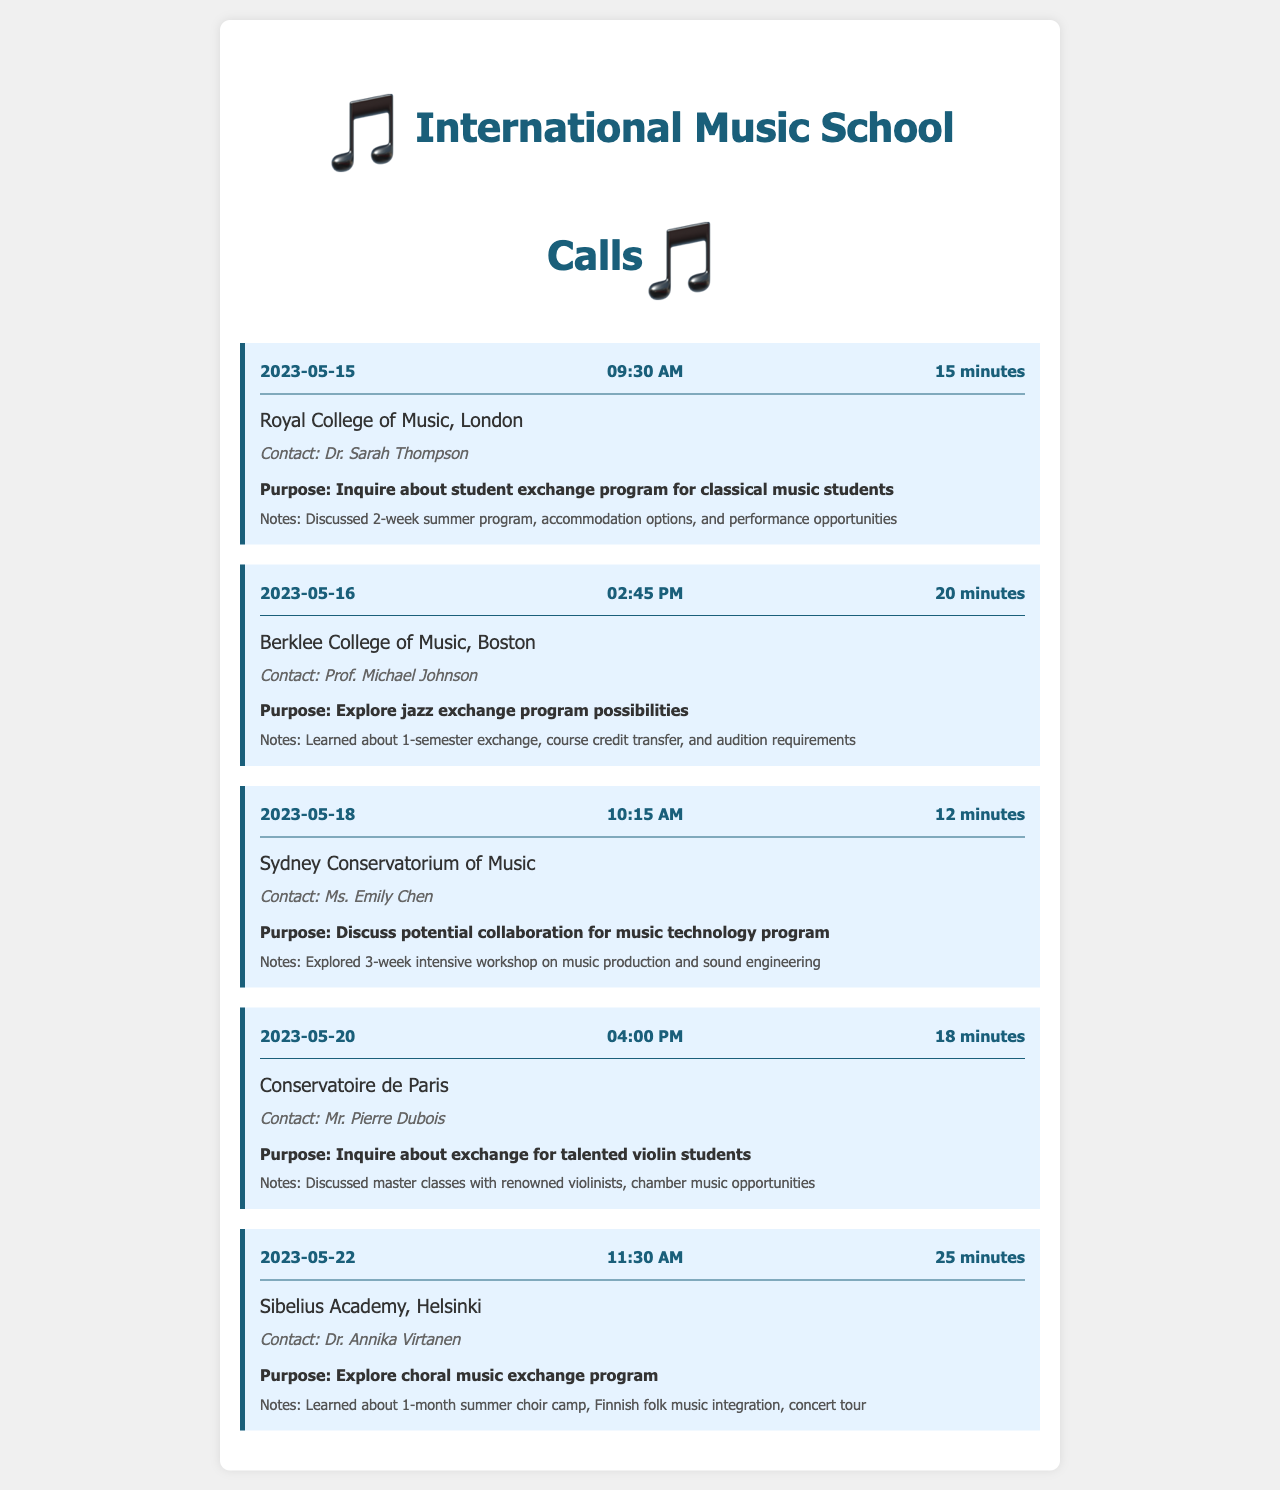What is the date of the call to the Royal College of Music? The date of the call to the Royal College of Music is specified in the document as May 15, 2023.
Answer: May 15, 2023 Who was the contact person for the call to Berklee College of Music? The document lists Professor Michael Johnson as the contact for the Berklee College of Music.
Answer: Prof. Michael Johnson What was the duration of the call to Sydney Conservatorium of Music? The document indicates that the duration of the call to Sydney Conservatorium of Music was 12 minutes.
Answer: 12 minutes What is the primary purpose of the call to Sibelius Academy? The purpose of the call to Sibelius Academy is stated as exploring a choral music exchange program.
Answer: Explore choral music exchange program How many calls were made in total? The total number of calls made is summed up from the individual call records presented in the document.
Answer: 5 calls What type of program was discussed during the call to Conservatoire de Paris? The document mentions that the call to Conservatoire de Paris involved an inquiry about an exchange for talented violin students.
Answer: Exchange for talented violin students What was discussed during the call regarding music technology at Sydney Conservatorium? The document notes that the call explored a 3-week intensive workshop on music production and sound engineering.
Answer: 3-week intensive workshop on music production and sound engineering Which music school discussed a summer choir camp? The document specifies that Sibelius Academy discussed a 1-month summer choir camp.
Answer: Sibelius Academy 